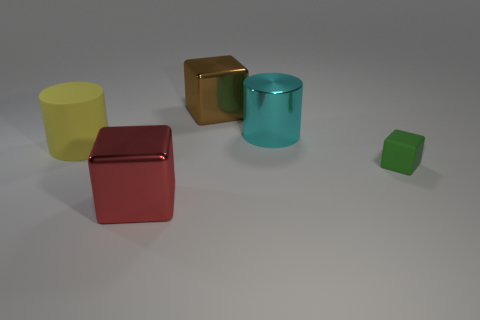How many red things are the same shape as the large cyan thing?
Provide a succinct answer. 0. There is a block that is the same material as the yellow object; what size is it?
Give a very brief answer. Small. Is there a object that is behind the big metal cube that is in front of the big metallic block that is behind the big red block?
Provide a short and direct response. Yes. Does the cyan metal object to the right of the yellow rubber cylinder have the same size as the yellow matte object?
Offer a terse response. Yes. What number of cylinders are the same size as the red object?
Provide a succinct answer. 2. The small thing is what shape?
Offer a very short reply. Cube. Are there more things on the right side of the red cube than big yellow rubber cylinders?
Your answer should be very brief. Yes. There is a brown object; does it have the same shape as the thing in front of the tiny matte object?
Your answer should be very brief. Yes. Are there any small purple matte things?
Your answer should be compact. No. What number of big objects are cylinders or red cylinders?
Make the answer very short. 2. 